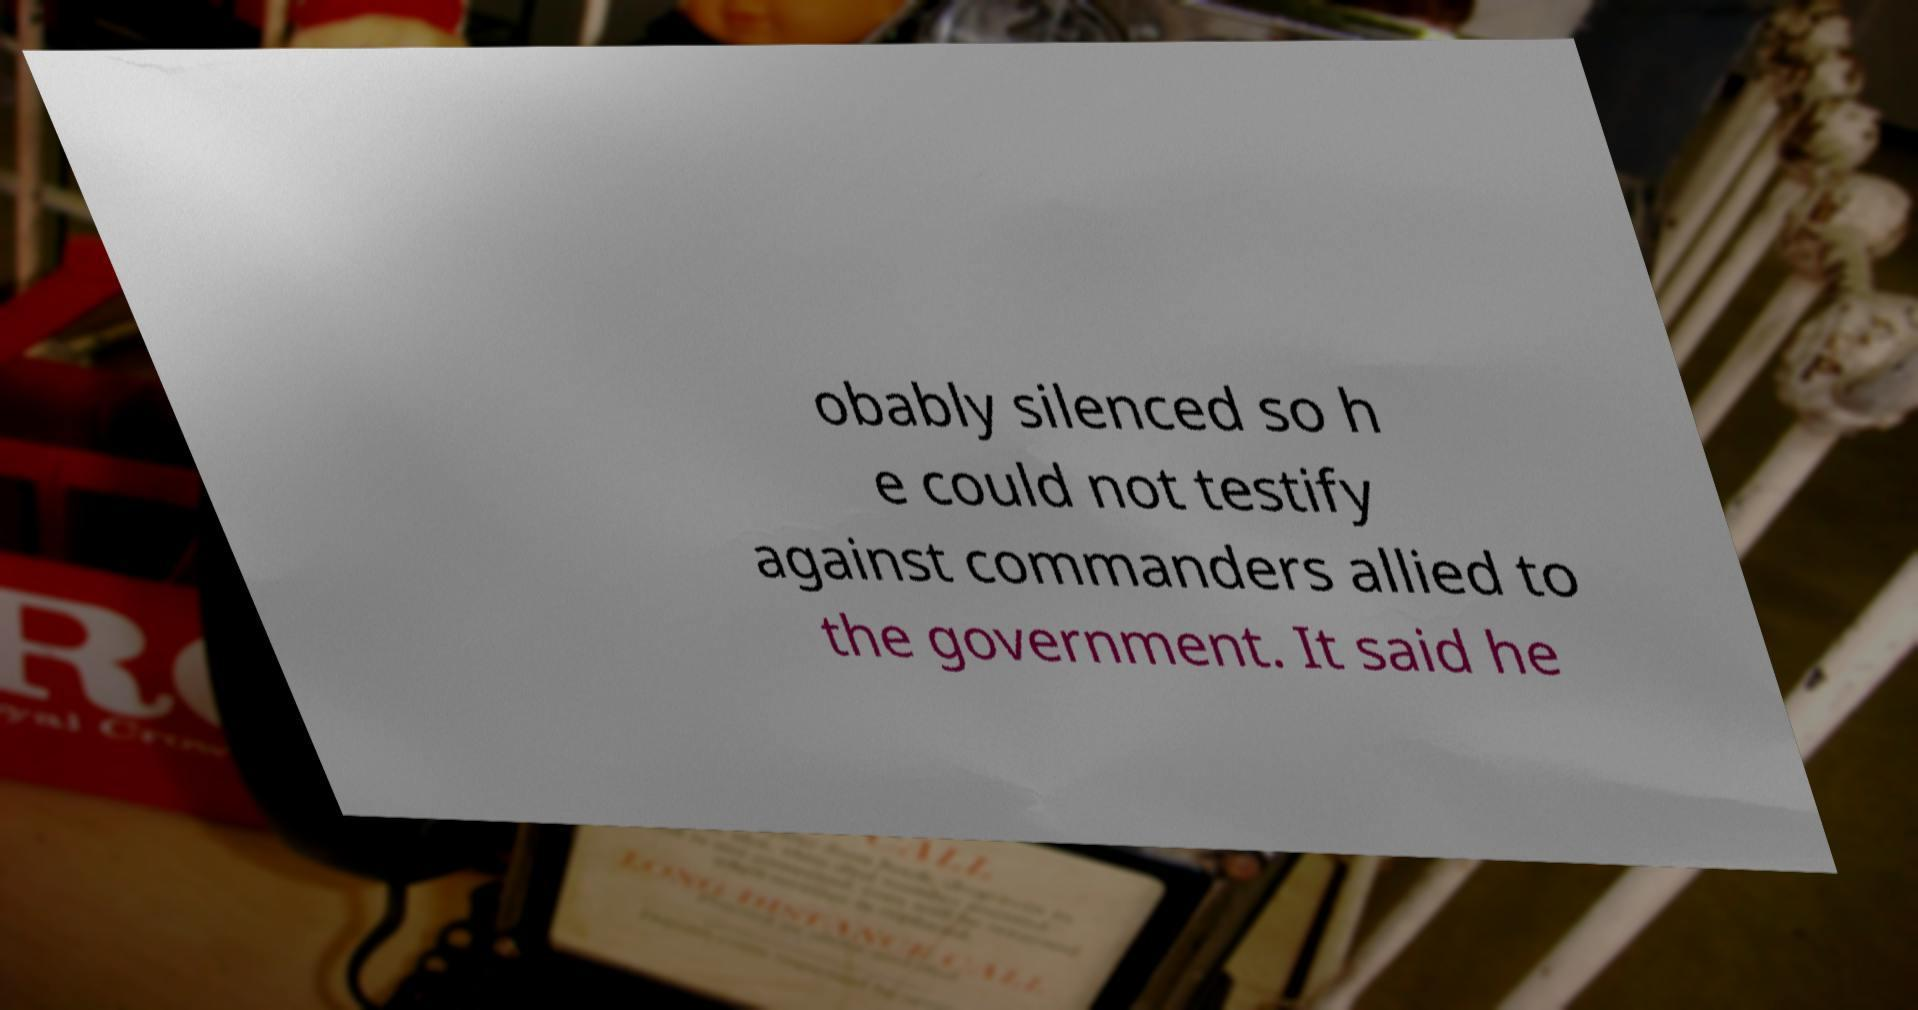Can you read and provide the text displayed in the image?This photo seems to have some interesting text. Can you extract and type it out for me? obably silenced so h e could not testify against commanders allied to the government. It said he 